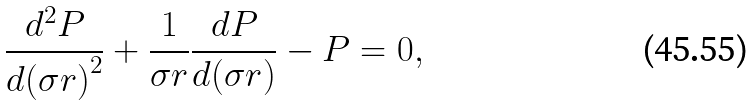Convert formula to latex. <formula><loc_0><loc_0><loc_500><loc_500>\frac { d ^ { 2 } P } { d { ( \sigma r ) } ^ { 2 } } + \frac { 1 } { \sigma r } \frac { d P } { d ( \sigma r ) } - P = 0 ,</formula> 